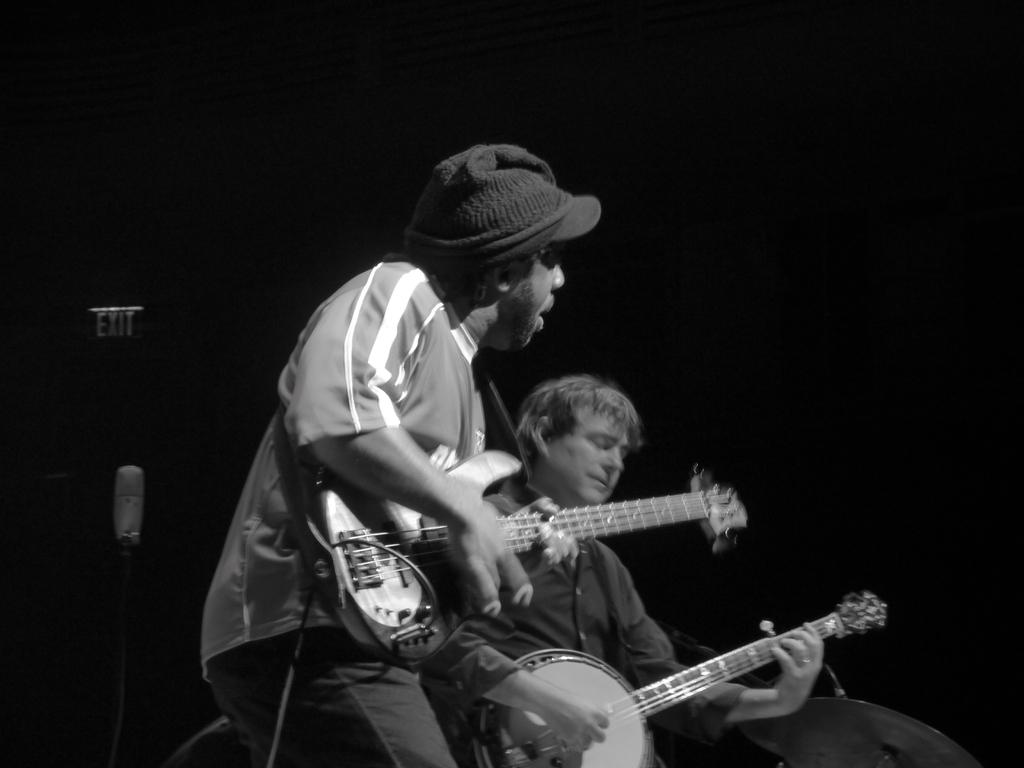What is the color scheme of the image? The image is black and white. How many people are in the image? There are two persons in the image. What are the two persons doing in the image? The two persons are playing a guitar. What type of bomb can be seen in the image? There is no bomb present in the image; it features two persons playing a guitar. What scent is associated with the birthday celebration in the image? There is no birthday celebration or scent mentioned in the image; it only shows two persons playing a guitar. 